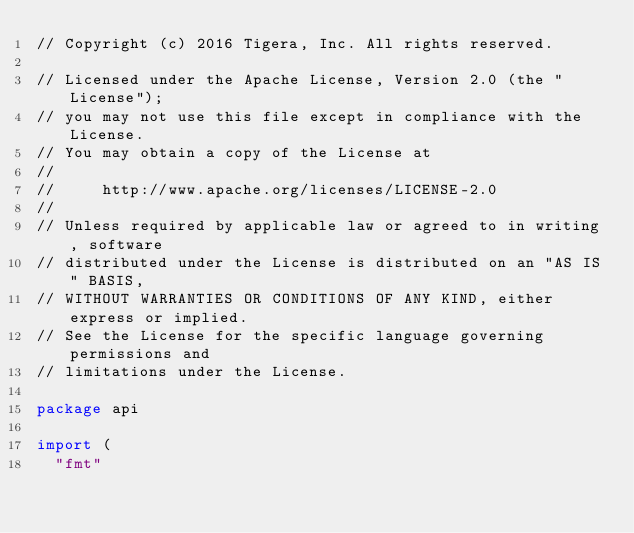<code> <loc_0><loc_0><loc_500><loc_500><_Go_>// Copyright (c) 2016 Tigera, Inc. All rights reserved.

// Licensed under the Apache License, Version 2.0 (the "License");
// you may not use this file except in compliance with the License.
// You may obtain a copy of the License at
//
//     http://www.apache.org/licenses/LICENSE-2.0
//
// Unless required by applicable law or agreed to in writing, software
// distributed under the License is distributed on an "AS IS" BASIS,
// WITHOUT WARRANTIES OR CONDITIONS OF ANY KIND, either express or implied.
// See the License for the specific language governing permissions and
// limitations under the License.

package api

import (
	"fmt"
</code> 